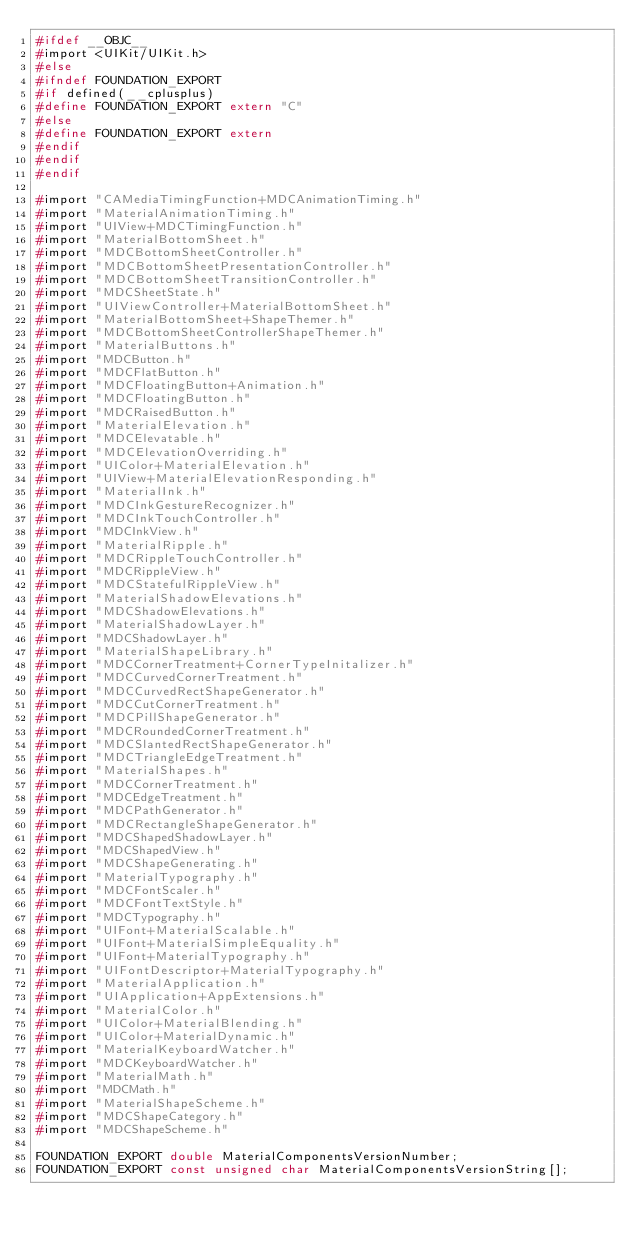<code> <loc_0><loc_0><loc_500><loc_500><_C_>#ifdef __OBJC__
#import <UIKit/UIKit.h>
#else
#ifndef FOUNDATION_EXPORT
#if defined(__cplusplus)
#define FOUNDATION_EXPORT extern "C"
#else
#define FOUNDATION_EXPORT extern
#endif
#endif
#endif

#import "CAMediaTimingFunction+MDCAnimationTiming.h"
#import "MaterialAnimationTiming.h"
#import "UIView+MDCTimingFunction.h"
#import "MaterialBottomSheet.h"
#import "MDCBottomSheetController.h"
#import "MDCBottomSheetPresentationController.h"
#import "MDCBottomSheetTransitionController.h"
#import "MDCSheetState.h"
#import "UIViewController+MaterialBottomSheet.h"
#import "MaterialBottomSheet+ShapeThemer.h"
#import "MDCBottomSheetControllerShapeThemer.h"
#import "MaterialButtons.h"
#import "MDCButton.h"
#import "MDCFlatButton.h"
#import "MDCFloatingButton+Animation.h"
#import "MDCFloatingButton.h"
#import "MDCRaisedButton.h"
#import "MaterialElevation.h"
#import "MDCElevatable.h"
#import "MDCElevationOverriding.h"
#import "UIColor+MaterialElevation.h"
#import "UIView+MaterialElevationResponding.h"
#import "MaterialInk.h"
#import "MDCInkGestureRecognizer.h"
#import "MDCInkTouchController.h"
#import "MDCInkView.h"
#import "MaterialRipple.h"
#import "MDCRippleTouchController.h"
#import "MDCRippleView.h"
#import "MDCStatefulRippleView.h"
#import "MaterialShadowElevations.h"
#import "MDCShadowElevations.h"
#import "MaterialShadowLayer.h"
#import "MDCShadowLayer.h"
#import "MaterialShapeLibrary.h"
#import "MDCCornerTreatment+CornerTypeInitalizer.h"
#import "MDCCurvedCornerTreatment.h"
#import "MDCCurvedRectShapeGenerator.h"
#import "MDCCutCornerTreatment.h"
#import "MDCPillShapeGenerator.h"
#import "MDCRoundedCornerTreatment.h"
#import "MDCSlantedRectShapeGenerator.h"
#import "MDCTriangleEdgeTreatment.h"
#import "MaterialShapes.h"
#import "MDCCornerTreatment.h"
#import "MDCEdgeTreatment.h"
#import "MDCPathGenerator.h"
#import "MDCRectangleShapeGenerator.h"
#import "MDCShapedShadowLayer.h"
#import "MDCShapedView.h"
#import "MDCShapeGenerating.h"
#import "MaterialTypography.h"
#import "MDCFontScaler.h"
#import "MDCFontTextStyle.h"
#import "MDCTypography.h"
#import "UIFont+MaterialScalable.h"
#import "UIFont+MaterialSimpleEquality.h"
#import "UIFont+MaterialTypography.h"
#import "UIFontDescriptor+MaterialTypography.h"
#import "MaterialApplication.h"
#import "UIApplication+AppExtensions.h"
#import "MaterialColor.h"
#import "UIColor+MaterialBlending.h"
#import "UIColor+MaterialDynamic.h"
#import "MaterialKeyboardWatcher.h"
#import "MDCKeyboardWatcher.h"
#import "MaterialMath.h"
#import "MDCMath.h"
#import "MaterialShapeScheme.h"
#import "MDCShapeCategory.h"
#import "MDCShapeScheme.h"

FOUNDATION_EXPORT double MaterialComponentsVersionNumber;
FOUNDATION_EXPORT const unsigned char MaterialComponentsVersionString[];

</code> 